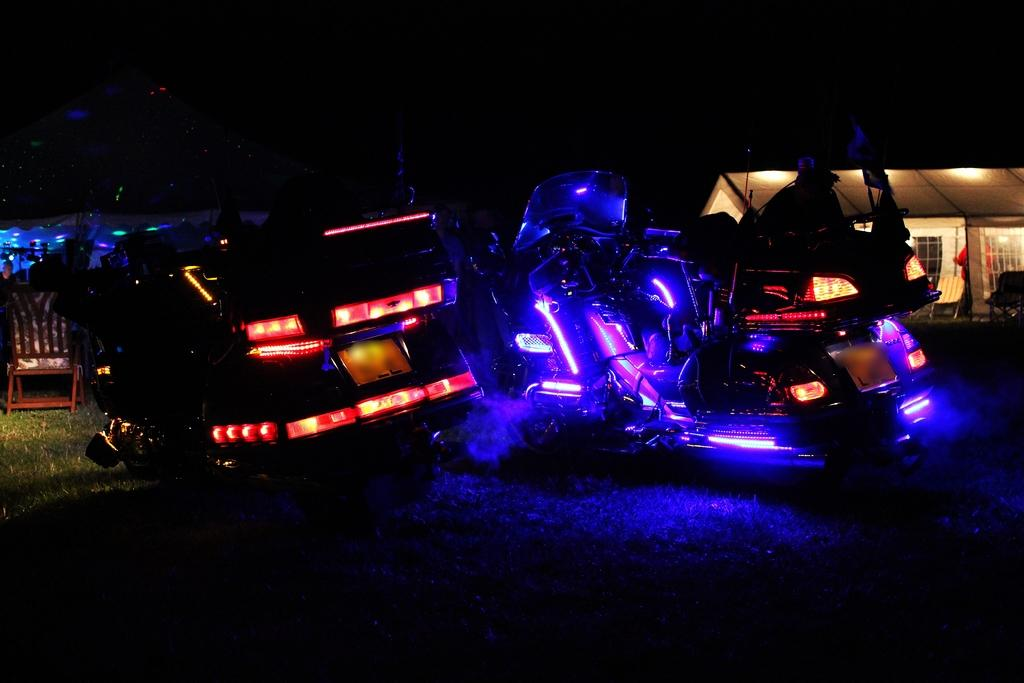What type of objects can be seen in the image? There are machines in the image. Can you describe the location of the chair in the image? The chair is on the grass path in the image. What structure is visible behind the machines in the image? There is a house behind the machines in the image. How would you describe the lighting in the image? The background of the image is dark. What type of loaf is being prepared by the committee in the image? There is no loaf or committee present in the image. What force is being applied to the machines in the image? There is no force being applied to the machines in the image; they are stationary. 